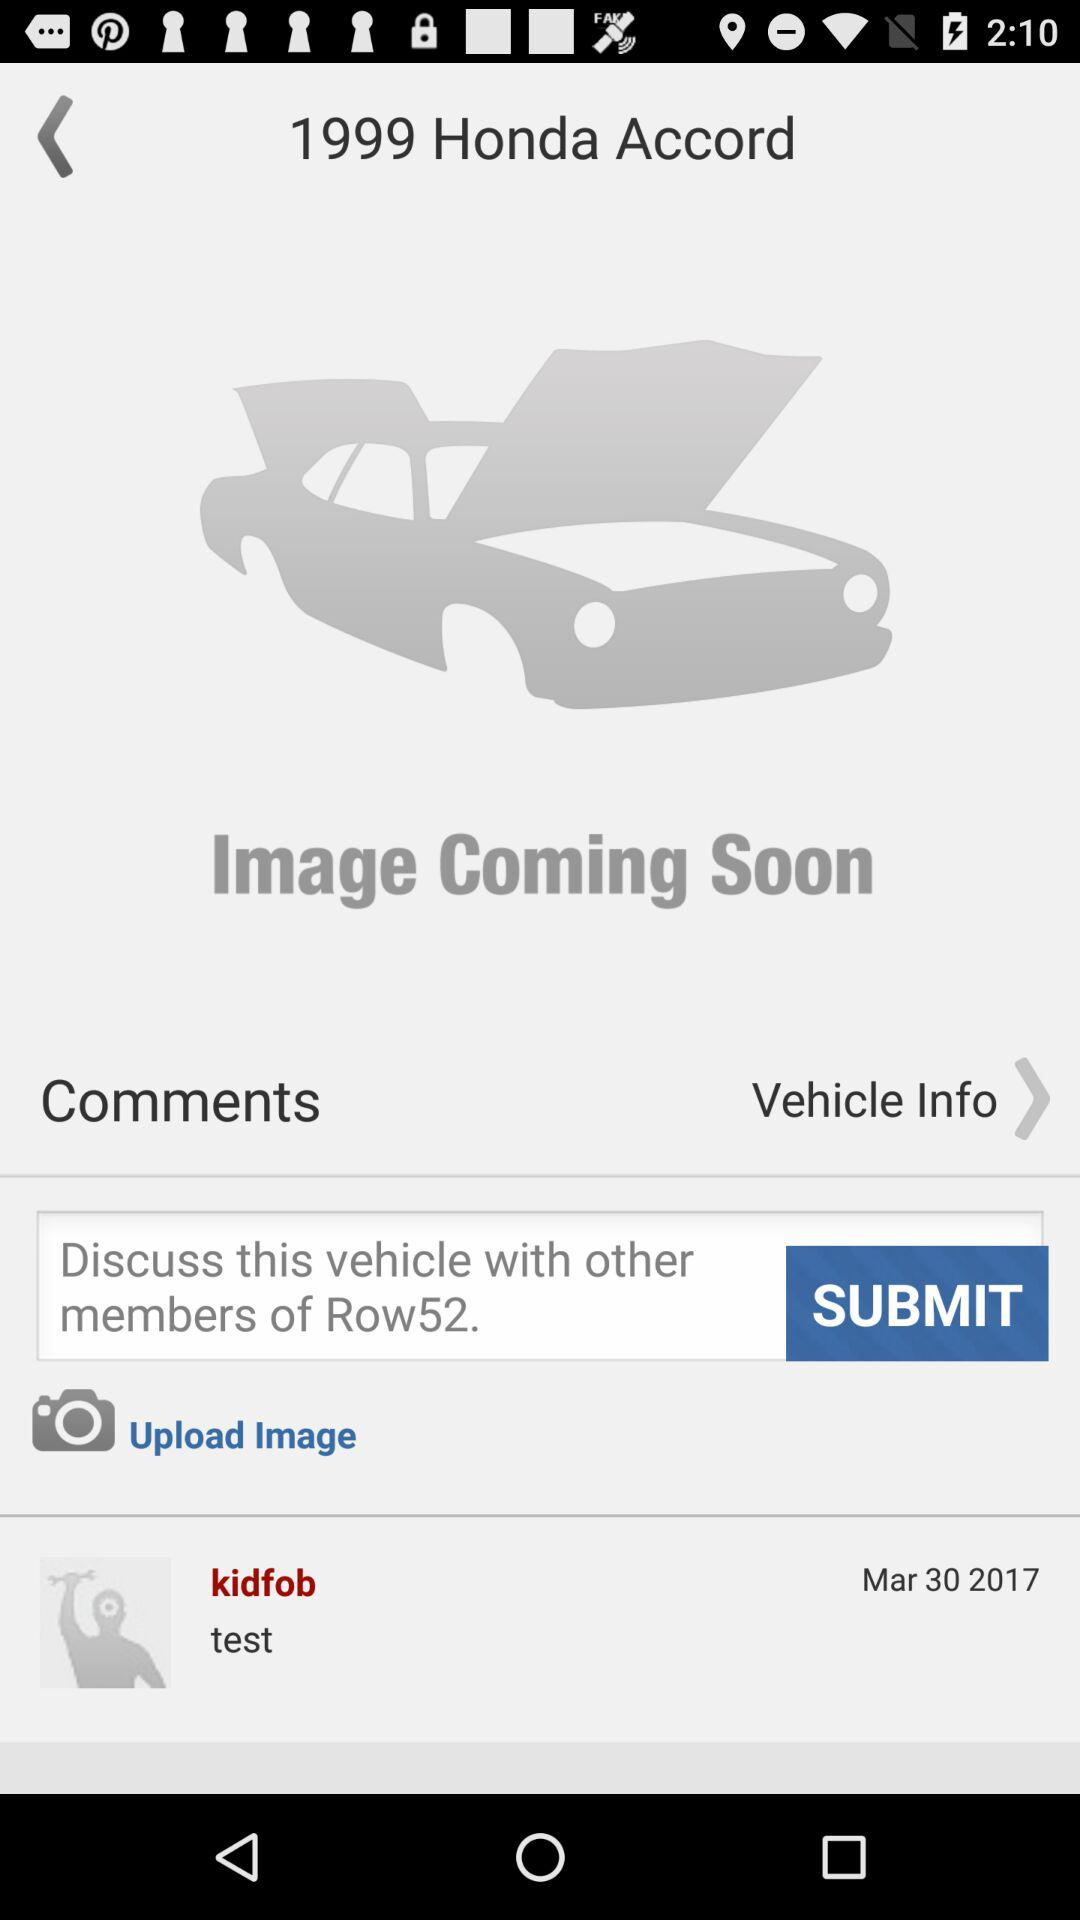How many comments are there for this vehicle?
Answer the question using a single word or phrase. 1 